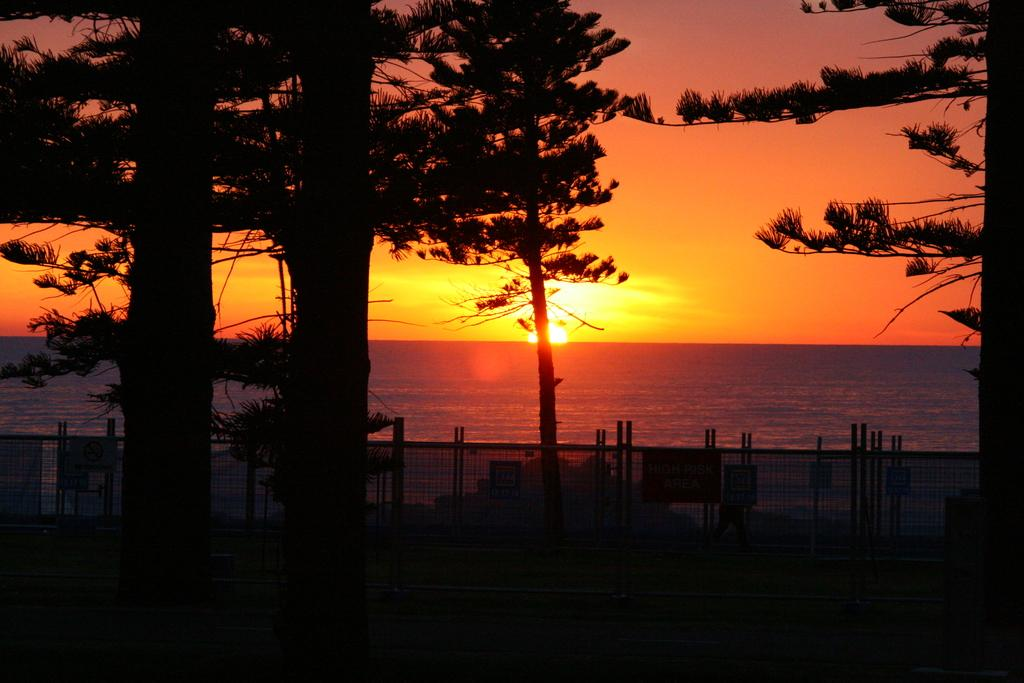What type of natural body of water is visible in the image? There is a sea in the image. What time of day is depicted in the image? There is a sunrise in the image. What type of vegetation can be seen in the image? There are many trees in the image. What type of barrier is present in the image? There is a fencing in the image. What is attached to the fencing in the image? There are boards attached to the fencing. What type of love can be seen in the image? There is no love present in the image. What type of sand can be seen in the image? There is no sand present in the image. What type of plants can be seen growing on the fencing in the image? There are no plants growing on the fencing in the image. 